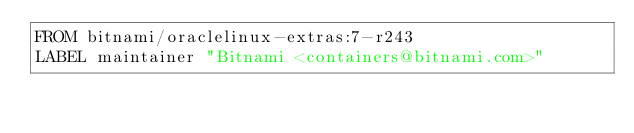<code> <loc_0><loc_0><loc_500><loc_500><_Dockerfile_>FROM bitnami/oraclelinux-extras:7-r243
LABEL maintainer "Bitnami <containers@bitnami.com>"
</code> 